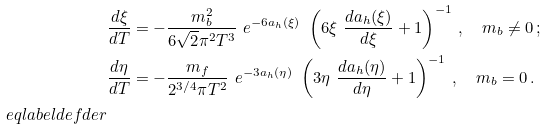<formula> <loc_0><loc_0><loc_500><loc_500>& \frac { d \xi } { d T } = - \frac { m _ { b } ^ { 2 } } { 6 \sqrt { 2 } \pi ^ { 2 } T ^ { 3 } } \ e ^ { - 6 a _ { h } ( \xi ) } \ \left ( 6 \xi \ \frac { d a _ { h } ( \xi ) } { d \xi } + 1 \right ) ^ { - 1 } \, , \quad m _ { b } \ne 0 \, ; \\ & \frac { d \eta } { d T } = - \frac { m _ { f } } { 2 ^ { 3 / 4 } \pi T ^ { 2 } } \ e ^ { - 3 a _ { h } ( \eta ) } \ \left ( 3 \eta \ \frac { d a _ { h } ( \eta ) } { d \eta } + 1 \right ) ^ { - 1 } \, , \quad m _ { b } = 0 \, . \\ \ e q l a b e l { d e f d e r }</formula> 